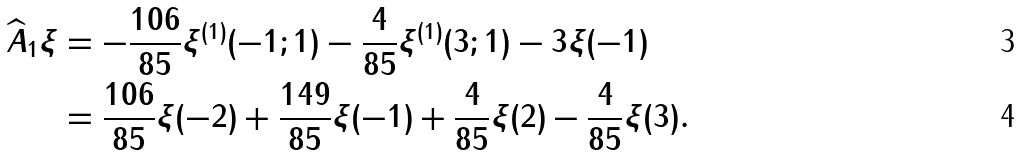Convert formula to latex. <formula><loc_0><loc_0><loc_500><loc_500>\widehat { A } _ { 1 } \xi & = - \frac { 1 0 6 } { 8 5 } \xi ^ { ( 1 ) } ( - 1 ; 1 ) - \frac { 4 } { 8 5 } \xi ^ { ( 1 ) } ( 3 ; 1 ) - 3 \xi ( - 1 ) \\ & = \frac { 1 0 6 } { 8 5 } \xi ( - 2 ) + \frac { 1 4 9 } { 8 5 } \xi ( - 1 ) + \frac { 4 } { 8 5 } \xi ( 2 ) - \frac { 4 } { 8 5 } \xi ( 3 ) .</formula> 